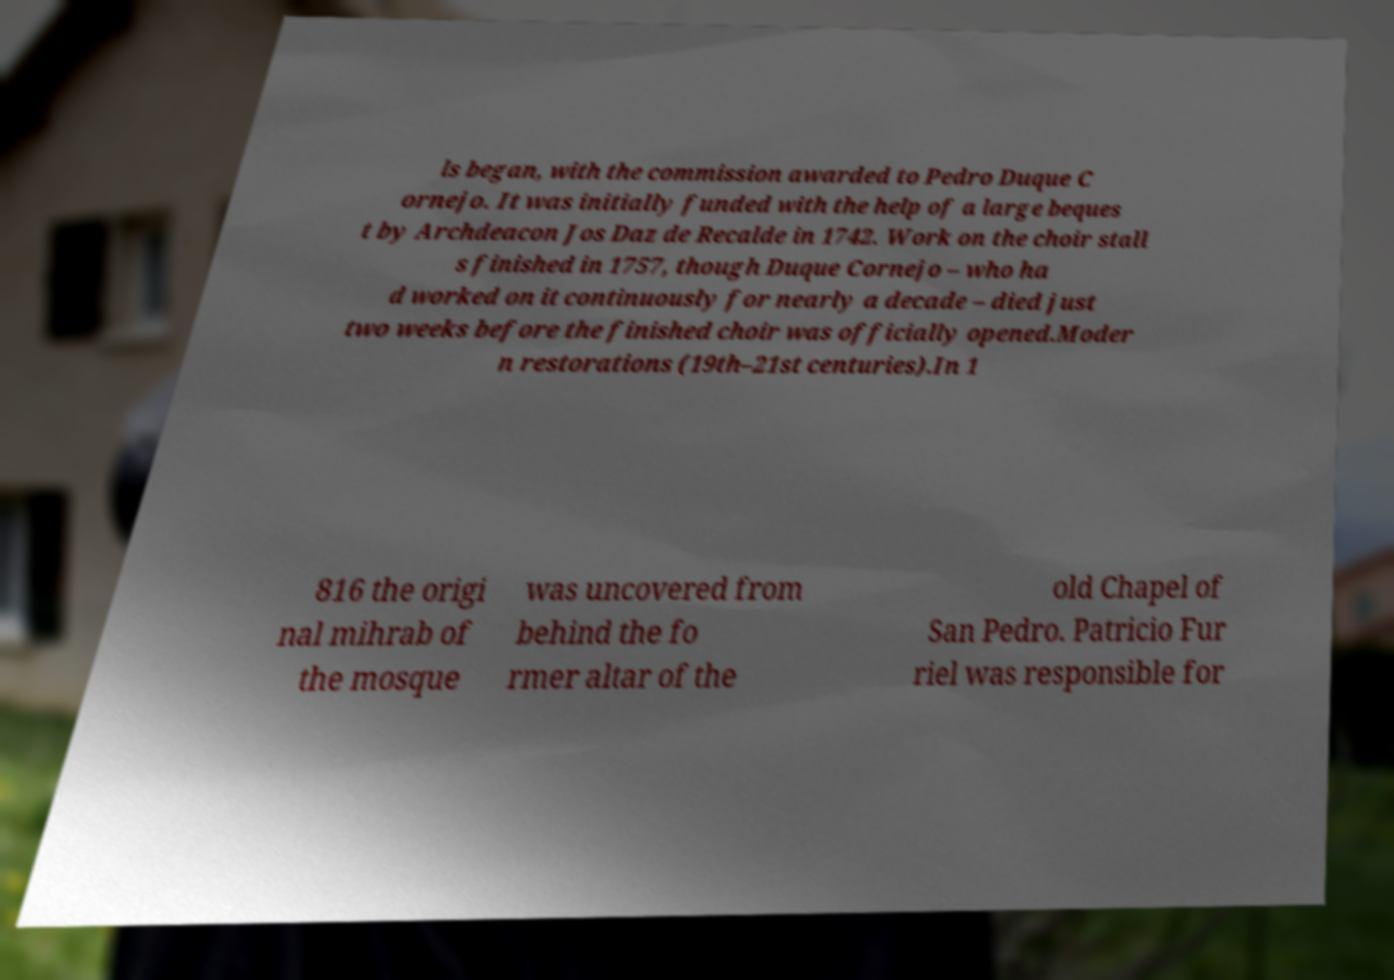Could you assist in decoding the text presented in this image and type it out clearly? ls began, with the commission awarded to Pedro Duque C ornejo. It was initially funded with the help of a large beques t by Archdeacon Jos Daz de Recalde in 1742. Work on the choir stall s finished in 1757, though Duque Cornejo – who ha d worked on it continuously for nearly a decade – died just two weeks before the finished choir was officially opened.Moder n restorations (19th–21st centuries).In 1 816 the origi nal mihrab of the mosque was uncovered from behind the fo rmer altar of the old Chapel of San Pedro. Patricio Fur riel was responsible for 